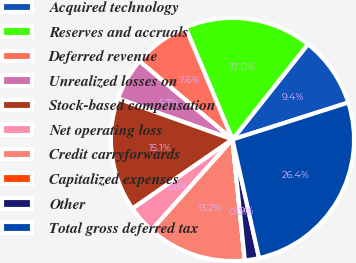Convert chart. <chart><loc_0><loc_0><loc_500><loc_500><pie_chart><fcel>Acquired technology<fcel>Reserves and accruals<fcel>Deferred revenue<fcel>Unrealized losses on<fcel>Stock-based compensation<fcel>Net operating loss<fcel>Credit carryforwards<fcel>Capitalized expenses<fcel>Other<fcel>Total gross deferred tax<nl><fcel>9.43%<fcel>16.98%<fcel>7.55%<fcel>5.66%<fcel>15.09%<fcel>3.78%<fcel>13.21%<fcel>0.01%<fcel>1.89%<fcel>26.4%<nl></chart> 